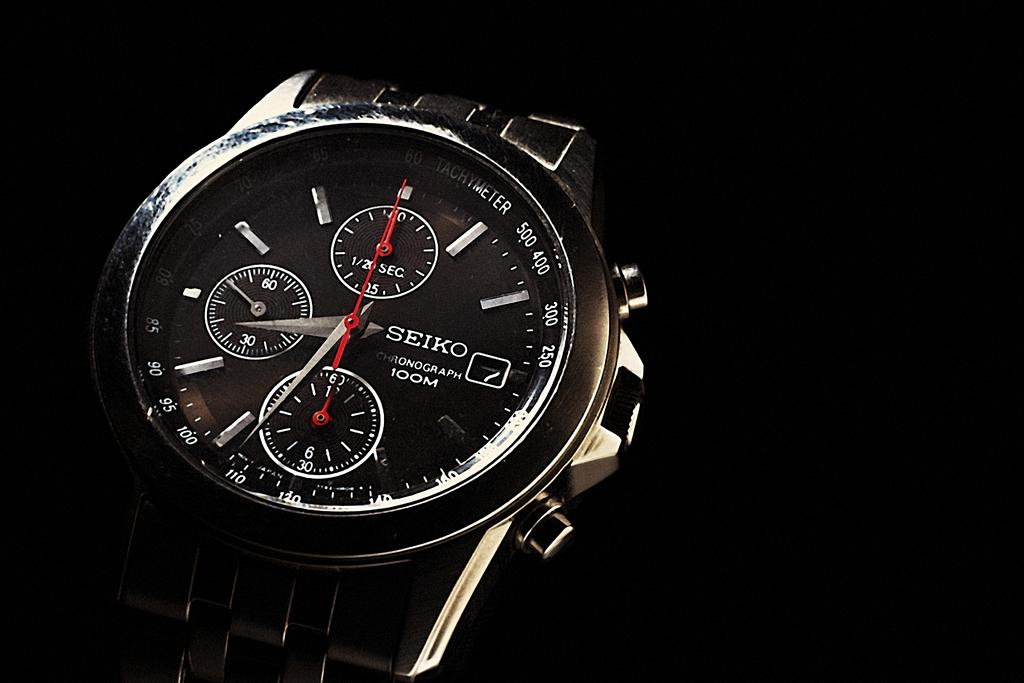<image>
Create a compact narrative representing the image presented. A watch face of a Seiko Chronograph 100M shows the time to be around 8:35. 